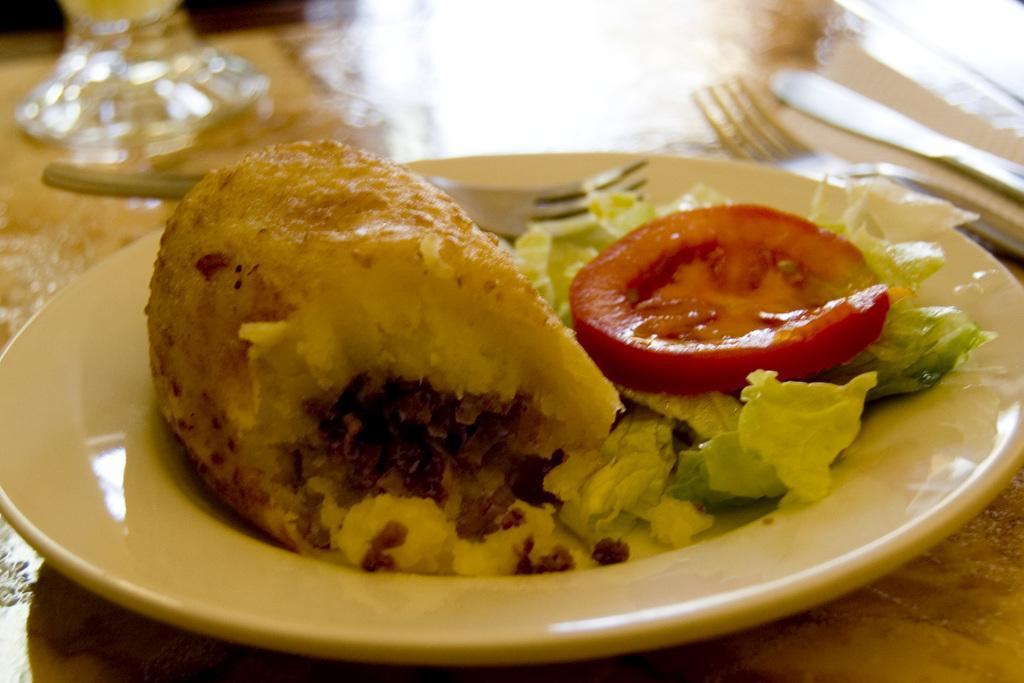Describe this image in one or two sentences. In this image I can see food which is in brown, green and red color in the plate and the plate is in white color and I can also see two forks. 